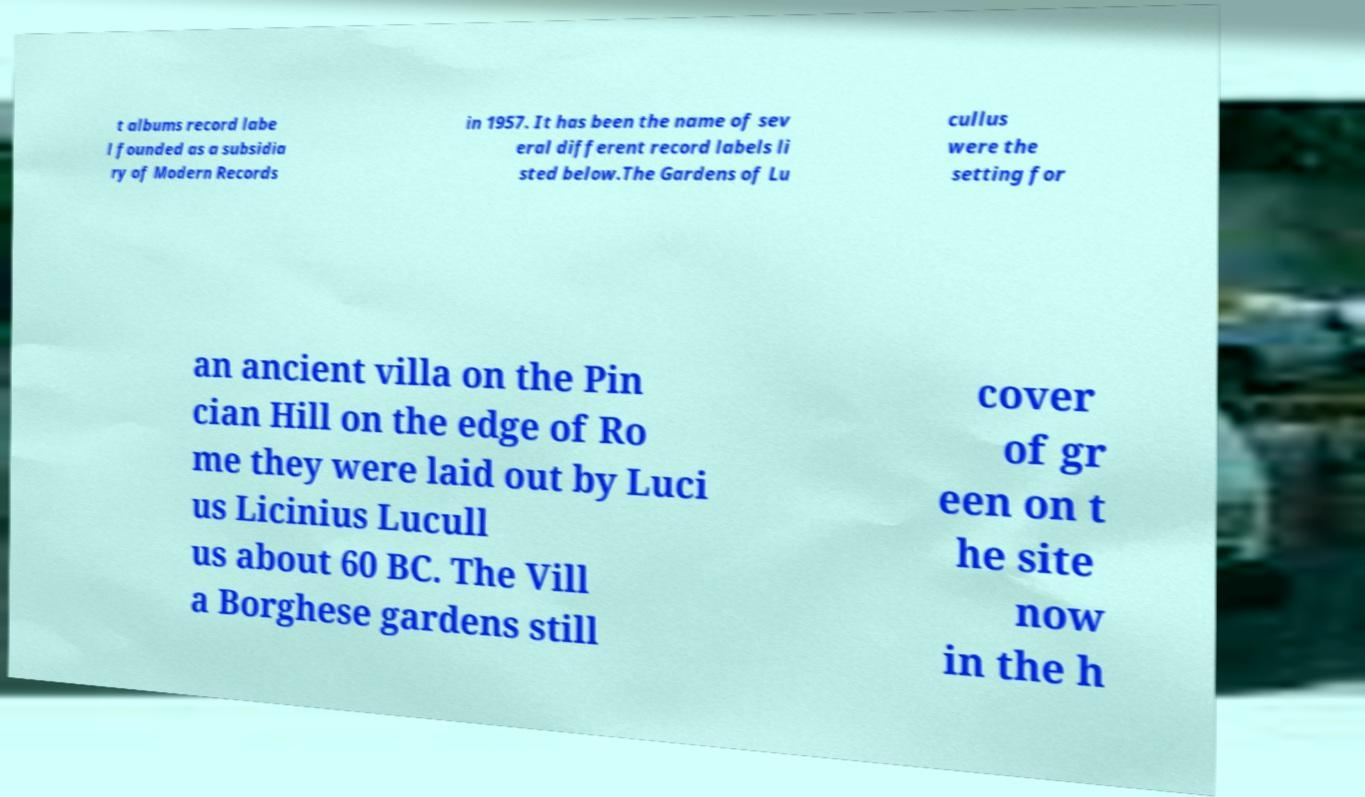What messages or text are displayed in this image? I need them in a readable, typed format. t albums record labe l founded as a subsidia ry of Modern Records in 1957. It has been the name of sev eral different record labels li sted below.The Gardens of Lu cullus were the setting for an ancient villa on the Pin cian Hill on the edge of Ro me they were laid out by Luci us Licinius Lucull us about 60 BC. The Vill a Borghese gardens still cover of gr een on t he site now in the h 